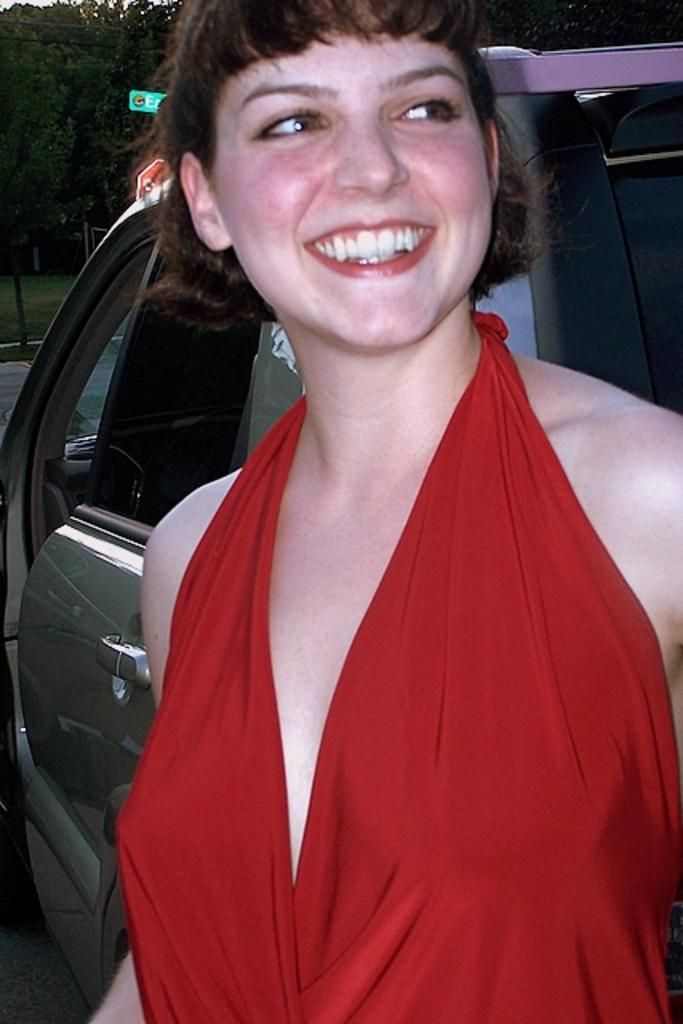What is the woman in the image doing? The woman is standing in the image and smiling. What can be seen behind the woman? There is a vehicle behind the woman. What type of natural environment is visible in the image? There are trees and grass in the image. What else can be seen in the image besides the woman and the vehicle? There are poles in the image. What type of wren is perched on the woman's shoulder in the image? There is no wren present in the image; it only features a woman, a vehicle, trees, grass, and poles. 